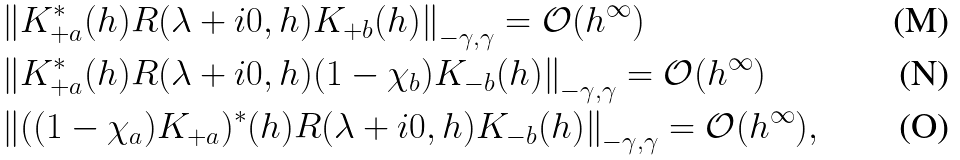Convert formula to latex. <formula><loc_0><loc_0><loc_500><loc_500>& \left \| K _ { + a } ^ { * } ( h ) R ( \lambda + i 0 , h ) K _ { + b } ( h ) \right \| _ { - \gamma , \gamma } = \mathcal { O } ( h ^ { \infty } ) \\ & \left \| K _ { + a } ^ { * } ( h ) R ( \lambda + i 0 , h ) ( 1 - \chi _ { b } ) K _ { - b } ( h ) \right \| _ { - \gamma , \gamma } = \mathcal { O } ( h ^ { \infty } ) \\ & \left \| ( ( 1 - \chi _ { a } ) K _ { + a } ) ^ { * } ( h ) R ( \lambda + i 0 , h ) K _ { - b } ( h ) \right \| _ { - \gamma , \gamma } = \mathcal { O } ( h ^ { \infty } ) ,</formula> 